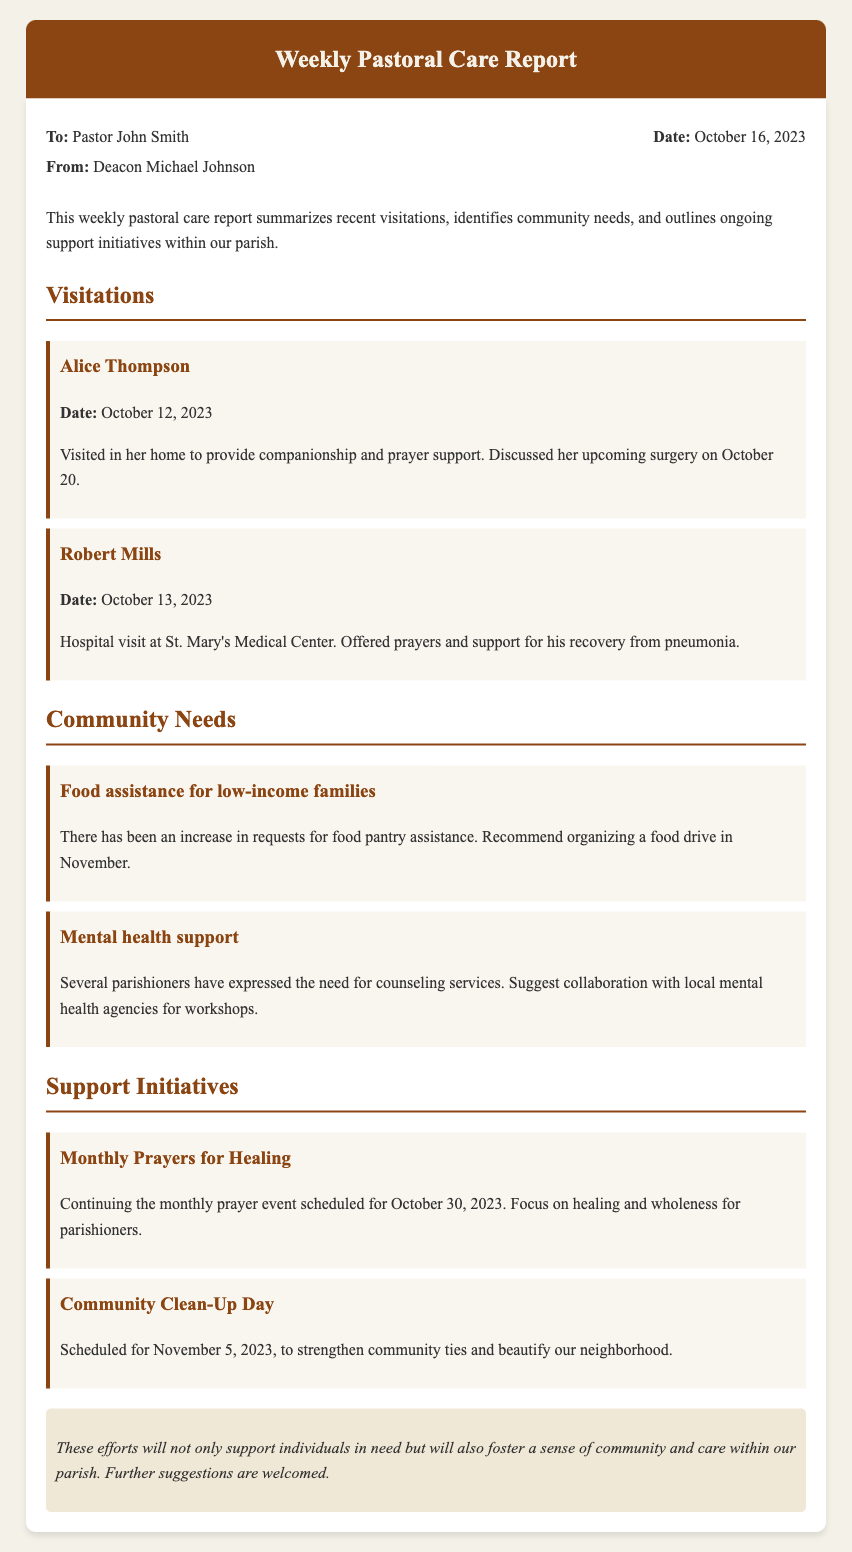What is the date of the report? The date of the report is stated clearly in the document.
Answer: October 16, 2023 Who visited Alice Thompson? The report specifies who performed the visitation.
Answer: Deacon Michael Johnson What community need is related to food? This section identifies specific community needs and their descriptions.
Answer: Food assistance for low-income families When is the Community Clean-Up Day scheduled? The document includes specific dates for planned initiatives.
Answer: November 5, 2023 What is discussed regarding Robert Mills? This visitation mentions specific details about the person's situation.
Answer: Recovery from pneumonia What is the focus of the Monthly Prayers for Healing? The purpose of the initiative is explicitly outlined in the report.
Answer: Healing and wholeness How many visitations are reported? Calculating the number of visitations in the document provides this count.
Answer: 2 What support initiative is planned for October 30, 2023? A specific event is indicated with its corresponding date in the report.
Answer: Monthly Prayers for Healing 